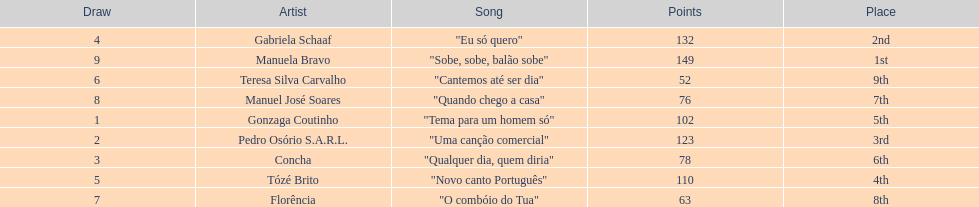What is the total amount of points for florencia? 63. 